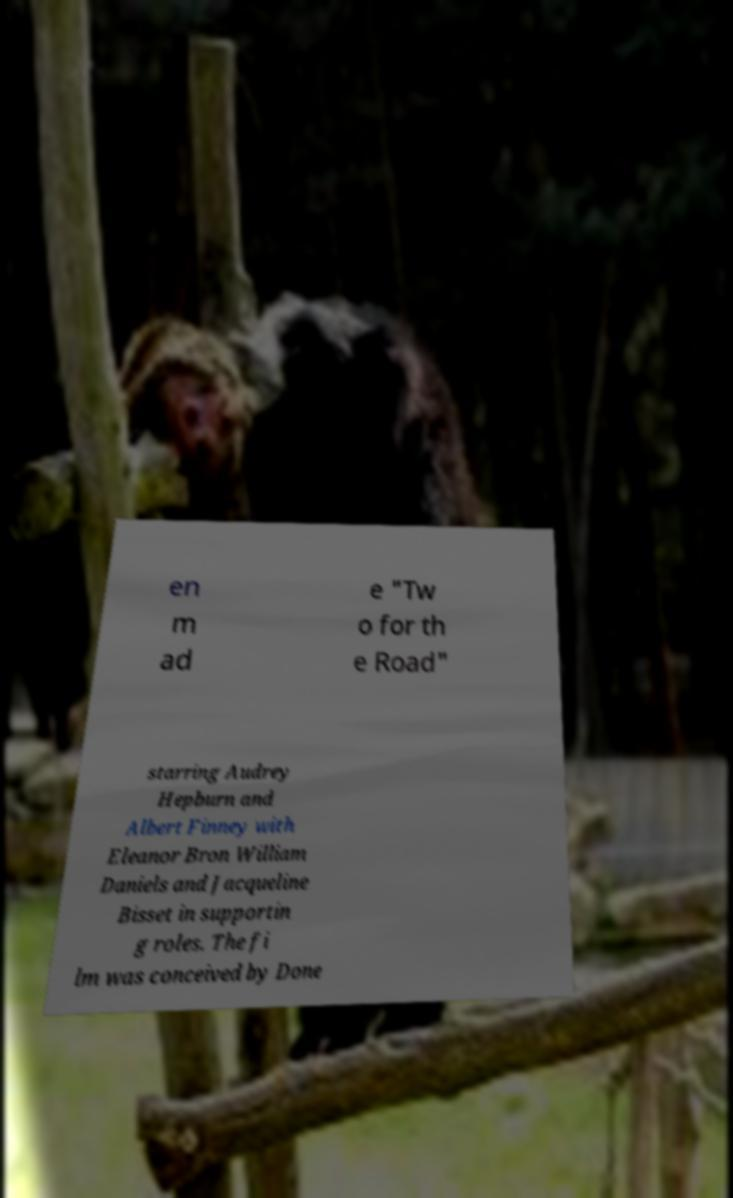Could you assist in decoding the text presented in this image and type it out clearly? en m ad e "Tw o for th e Road" starring Audrey Hepburn and Albert Finney with Eleanor Bron William Daniels and Jacqueline Bisset in supportin g roles. The fi lm was conceived by Done 